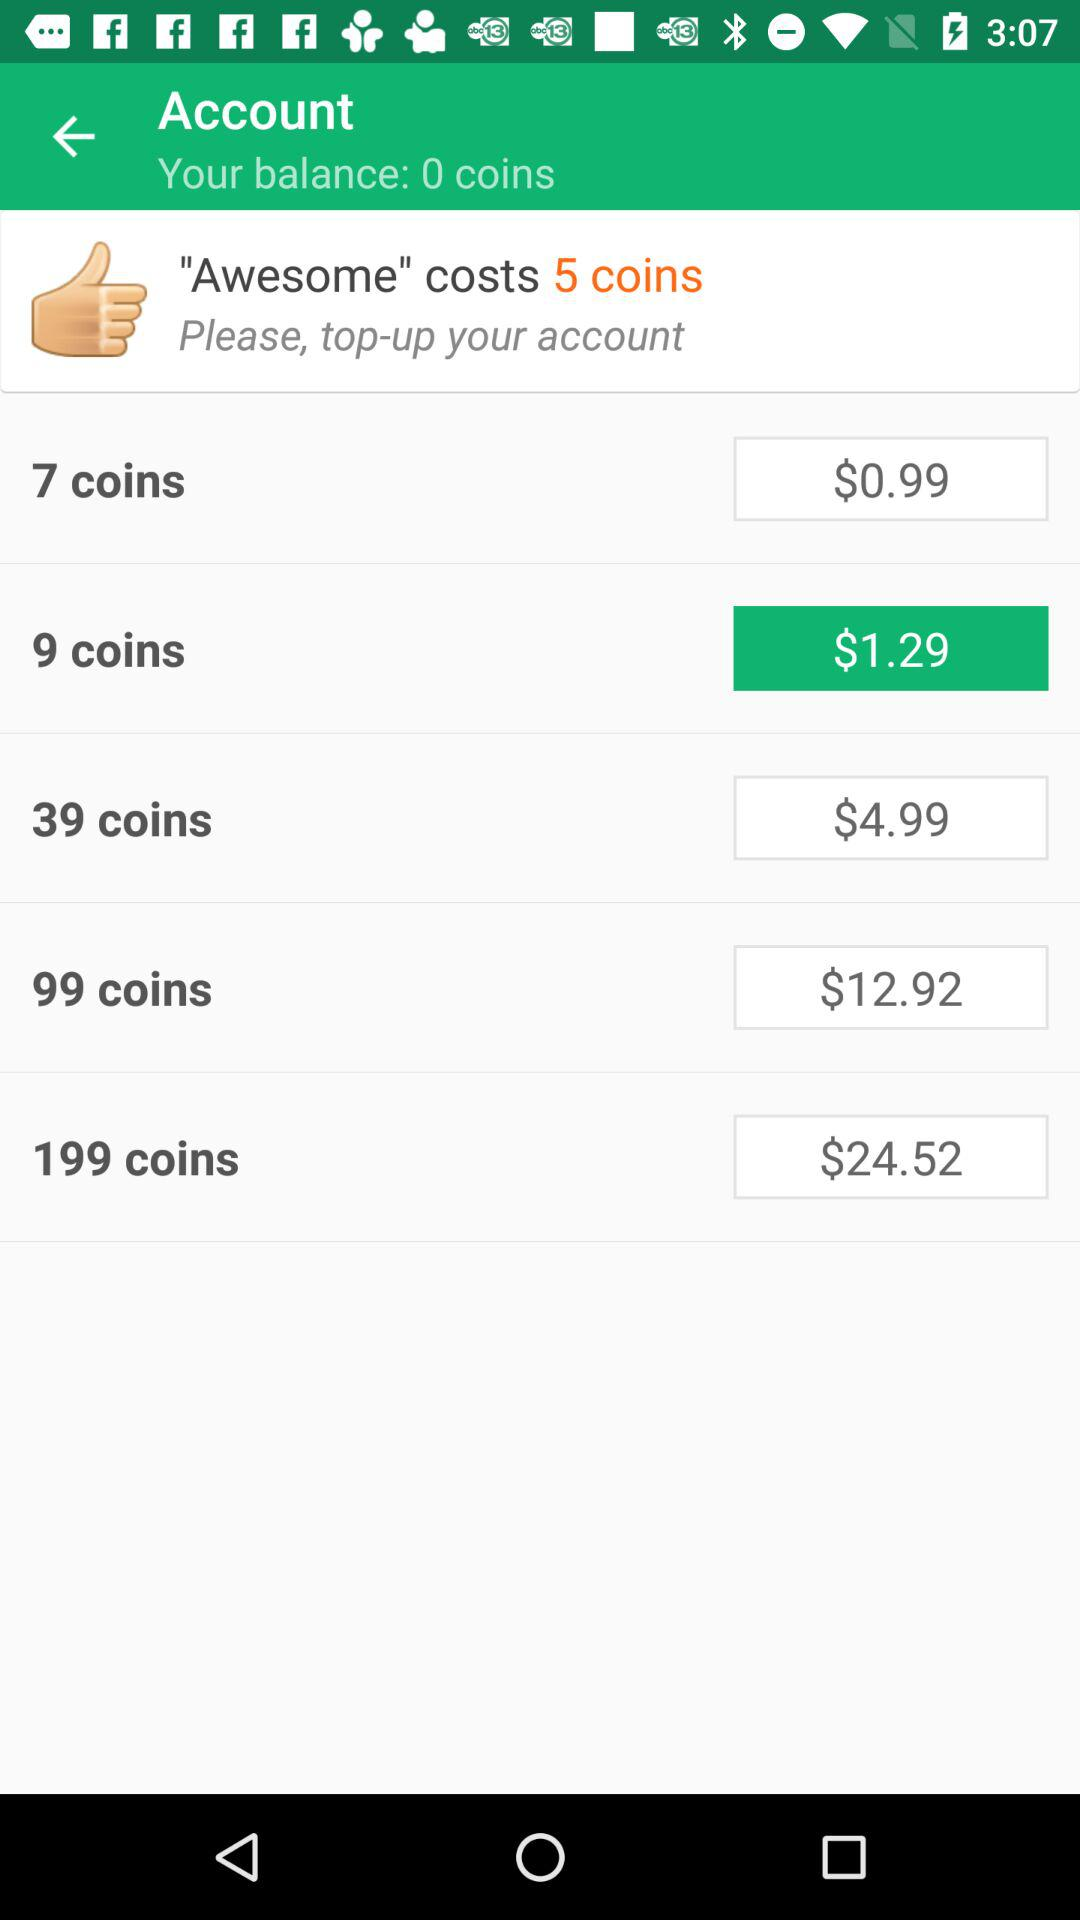What does the 'Awesome' item cost in terms of real currency? The 'Awesome' item costs 5 coins, and since the price for 7 coins is $0.99, you would spend less than a dollar in real currency for it. 